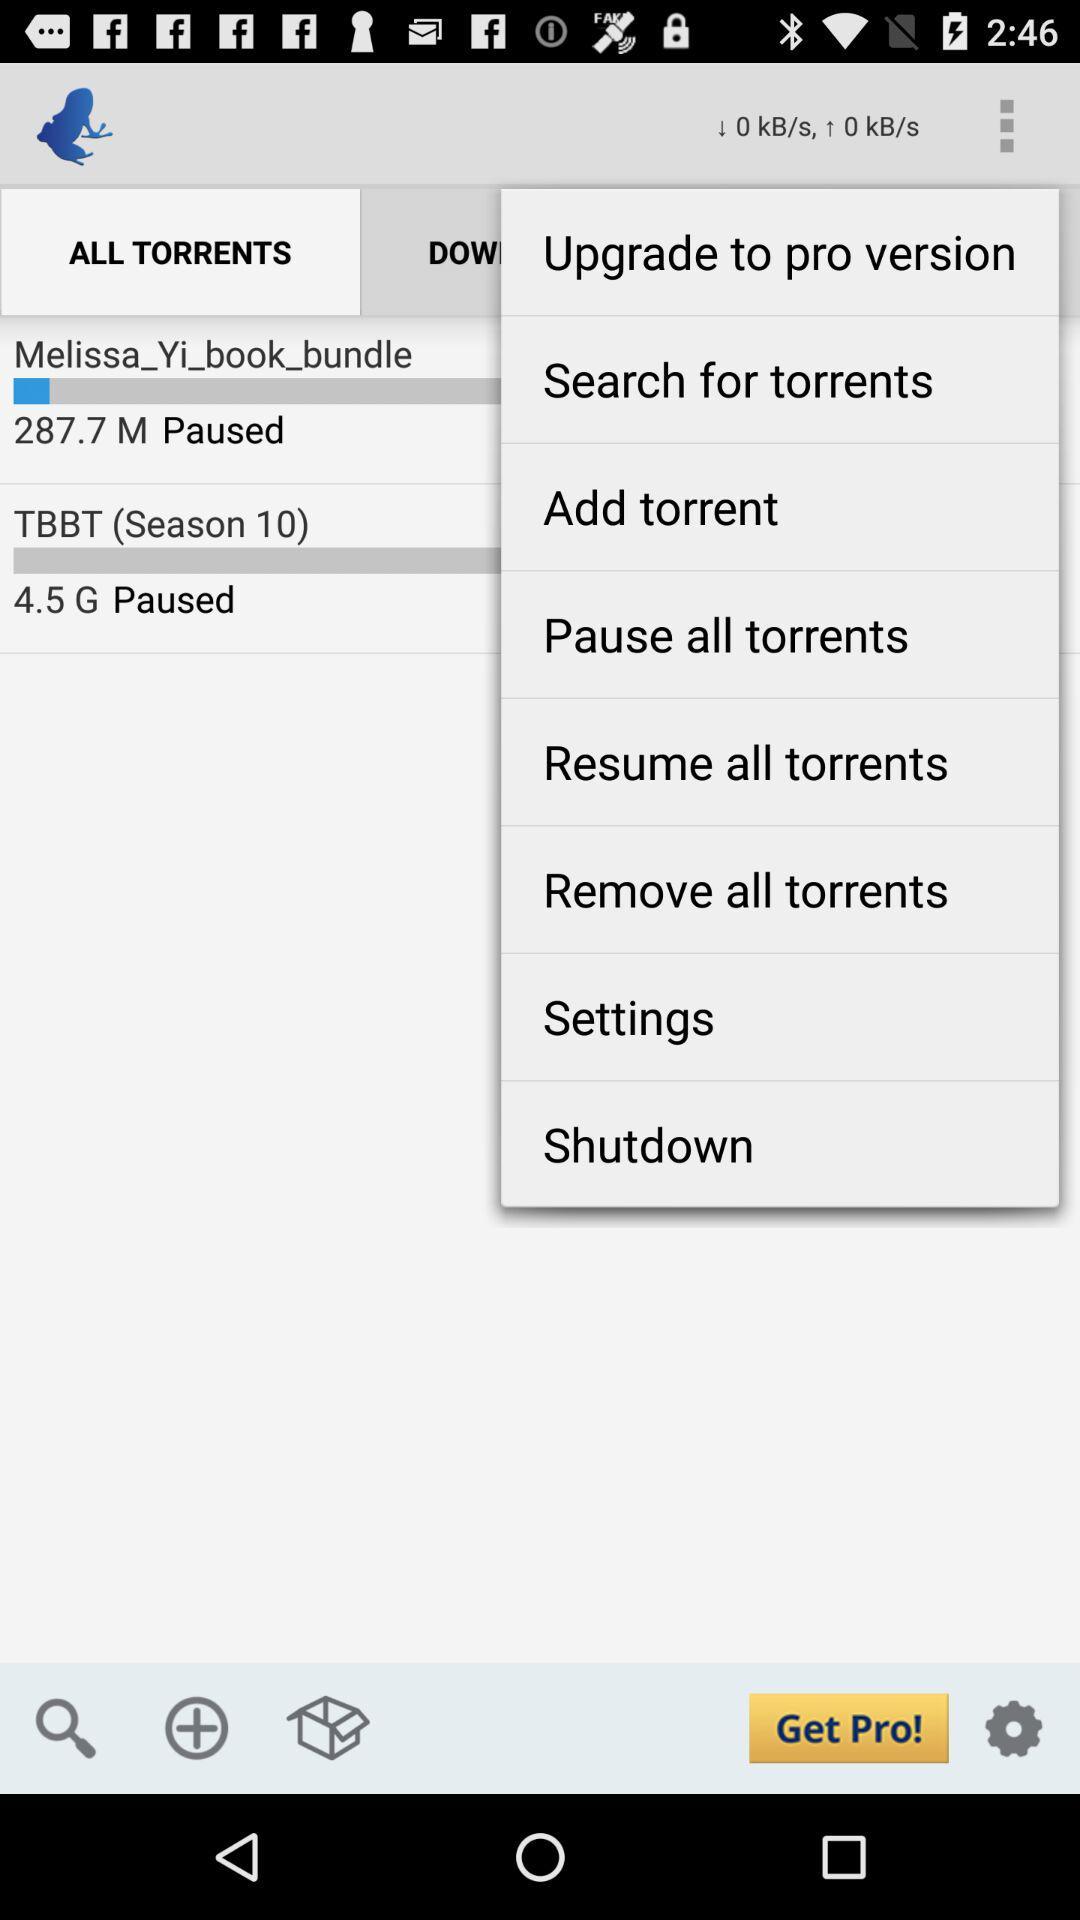Which tab is selected? The selected tab is "ALL TORRENTS". 